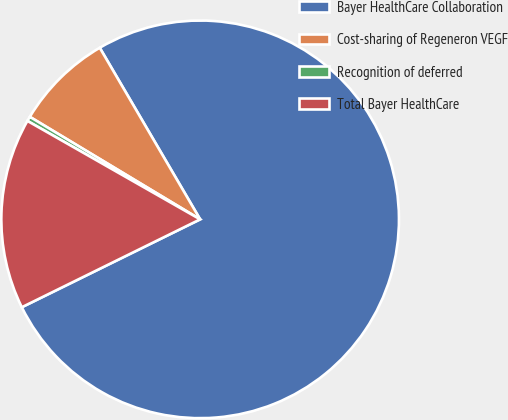Convert chart to OTSL. <chart><loc_0><loc_0><loc_500><loc_500><pie_chart><fcel>Bayer HealthCare Collaboration<fcel>Cost-sharing of Regeneron VEGF<fcel>Recognition of deferred<fcel>Total Bayer HealthCare<nl><fcel>76.14%<fcel>7.95%<fcel>0.38%<fcel>15.53%<nl></chart> 